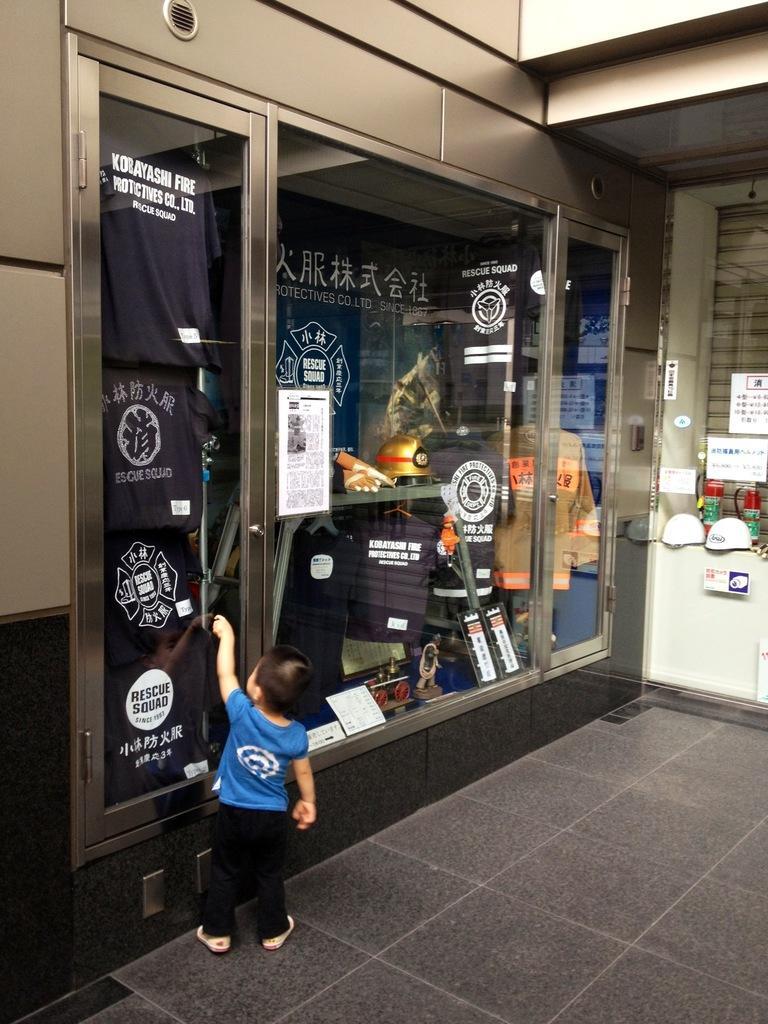Please provide a concise description of this image. In this image there is a boy standing near a cupboard. To the wall there is a cupboard. There are glass doors to the cupboard. Inside the cupboard there is a banner to the wall. In the cupboard there are t-shirts, a helmet, gloves, trophies, files and papers. On the door of the cupboard there is a poster sticker. There is text on the t-shirts. To the right there is a glass window. Near the window there are helmets and bottles. 